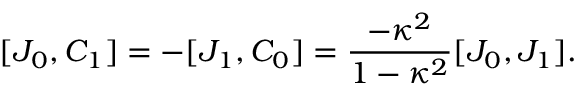<formula> <loc_0><loc_0><loc_500><loc_500>[ J _ { 0 } , C _ { 1 } ] = - [ J _ { 1 } , C _ { 0 } ] = { \frac { - \kappa ^ { 2 } } { 1 - \kappa ^ { 2 } } } [ J _ { 0 } , J _ { 1 } ] .</formula> 